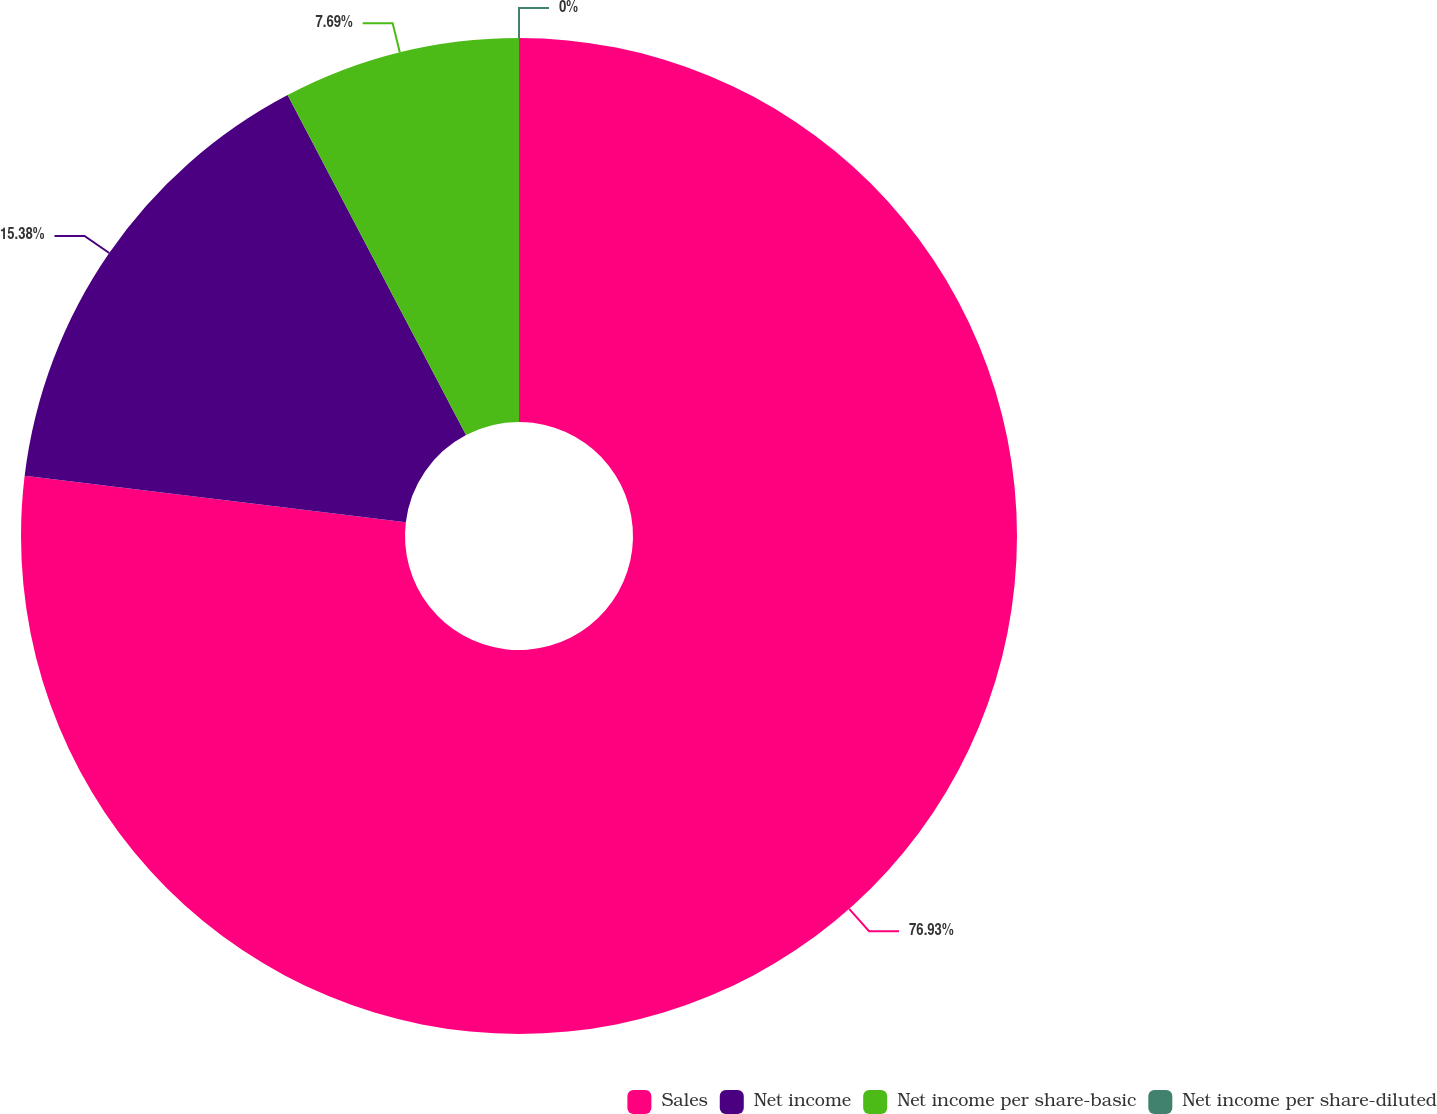Convert chart to OTSL. <chart><loc_0><loc_0><loc_500><loc_500><pie_chart><fcel>Sales<fcel>Net income<fcel>Net income per share-basic<fcel>Net income per share-diluted<nl><fcel>76.92%<fcel>15.38%<fcel>7.69%<fcel>0.0%<nl></chart> 